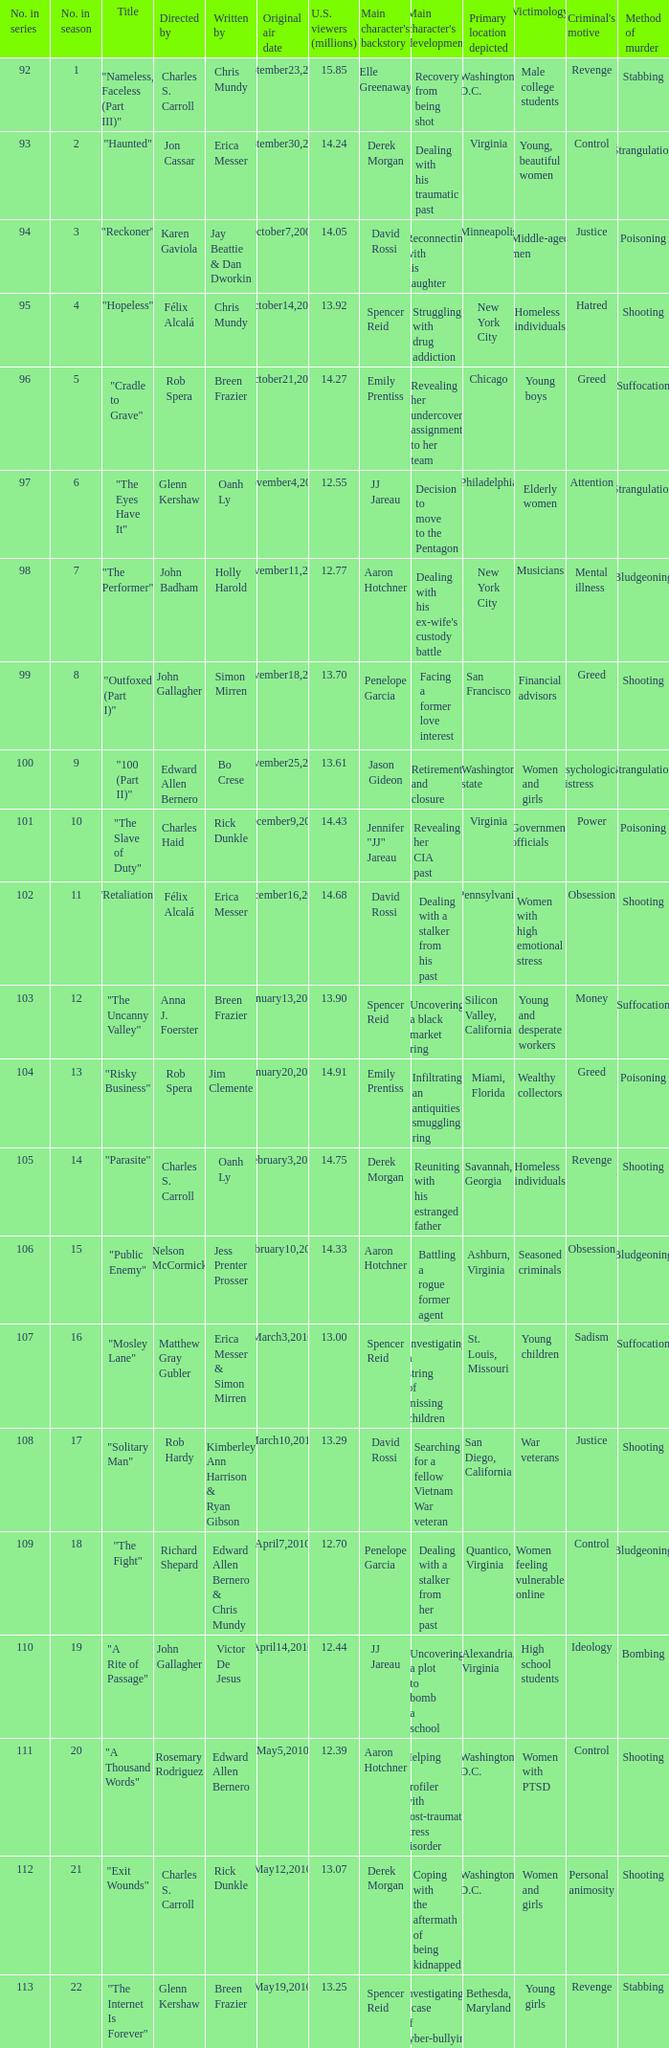Nelson mccormick directed the first episode of which season? 15.0. 